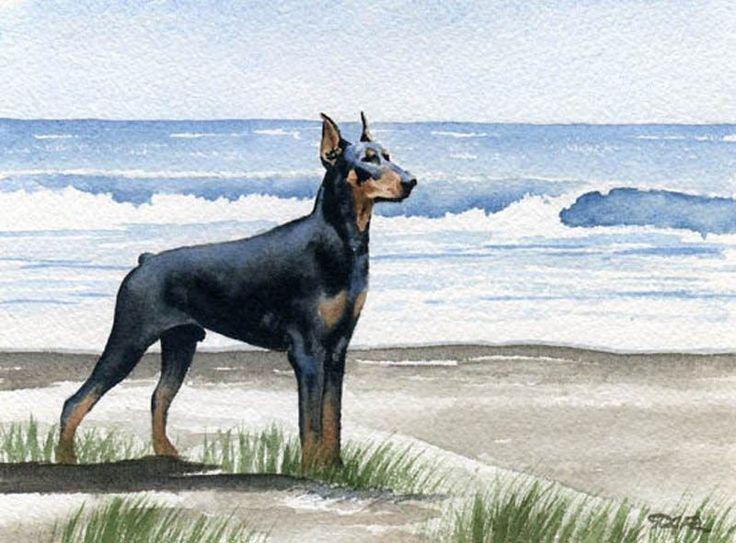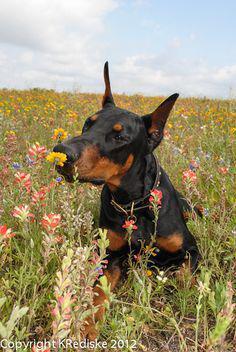The first image is the image on the left, the second image is the image on the right. Considering the images on both sides, is "There are two or more dogs standing in the left image and laying down in the right." valid? Answer yes or no. No. The first image is the image on the left, the second image is the image on the right. Given the left and right images, does the statement "The left image contains at least two dogs." hold true? Answer yes or no. No. 